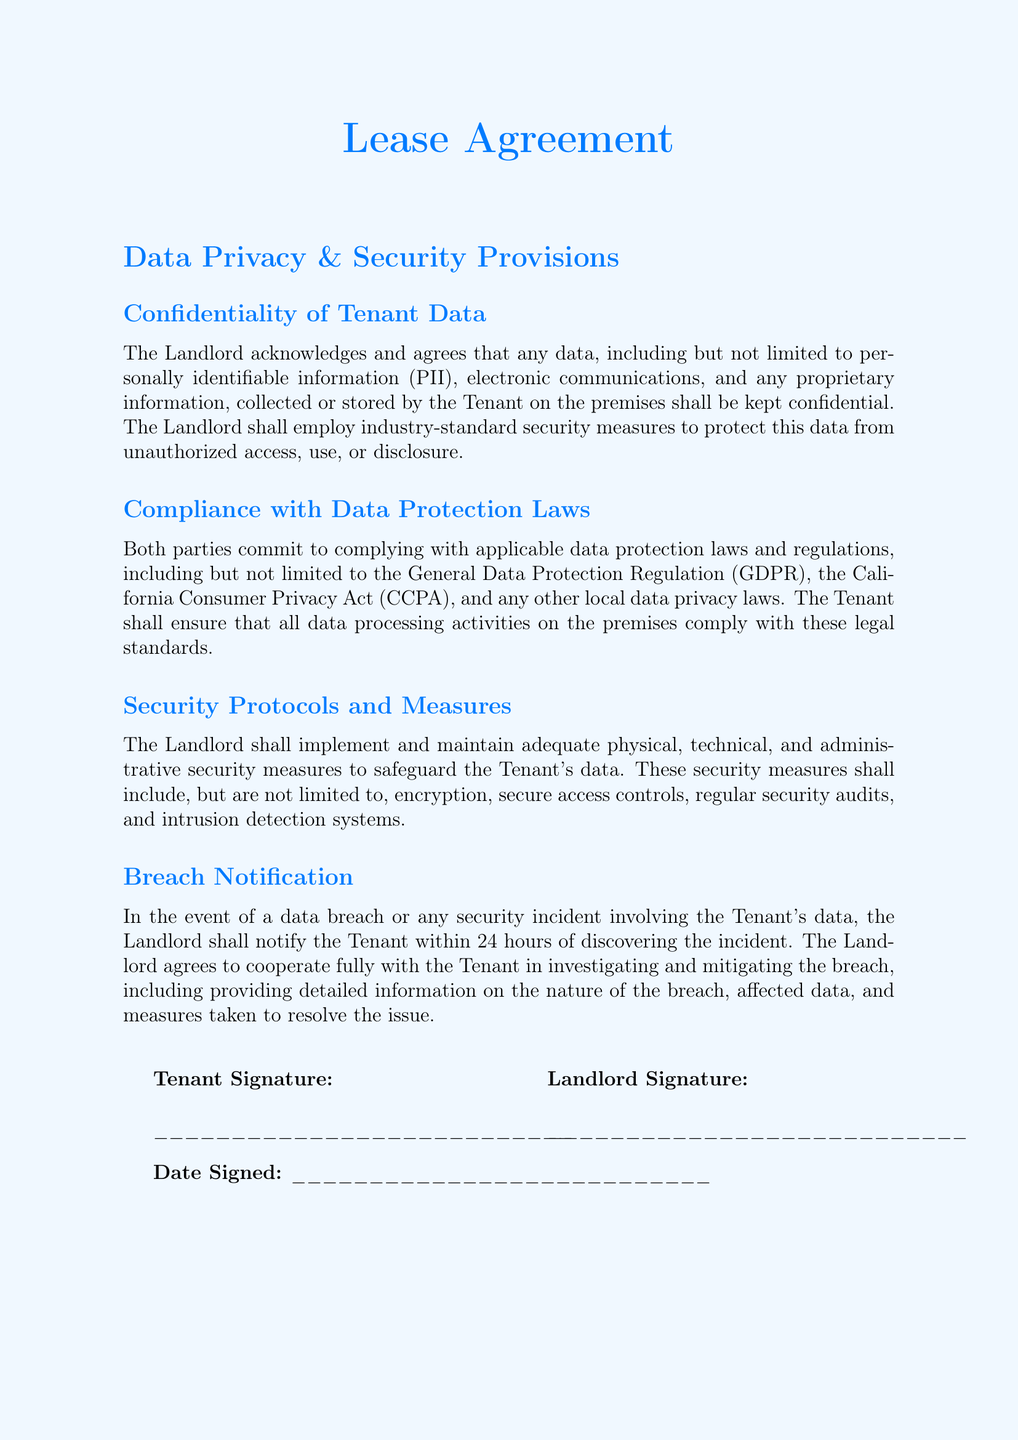What is the title of the document? The title of the document is specified at the beginning of the document in a prominent font.
Answer: Lease Agreement What data protections laws are mentioned? The document specifies applicable data protection laws that both parties must comply with.
Answer: GDPR, CCPA Within how many hours must the landlord notify the tenant of a data breach? The document explicitly states the time frame for breach notification after discovering the incident.
Answer: 24 hours What must the landlord implement to protect tenant data? The landlord is required to maintain certain measures to safeguard data according to the document.
Answer: Security measures Who acknowledges confidentiality of tenant data? The party that recognizes the confidentiality regarding tenant data is clearly stated in the document.
Answer: Landlord What type of signatures are required at the end of the document? The document indicates what type of signatures are necessary from both parties and their significance.
Answer: Tenant and Landlord What is included in the security measures? The document lists specific types of measures that fall under security to protect data, indicating their comprehensiveness.
Answer: Encryption, secure access controls, regular security audits, intrusion detection systems What kind of data is considered confidential? The types of data protected under the confidentiality clause are outlined in the document.
Answer: Personally identifiable information (PII) Who must cooperate in investigating a data breach? The responsibilities of the parties involved in the investigation process after a data breach are specified in the document.
Answer: Landlord and Tenant 